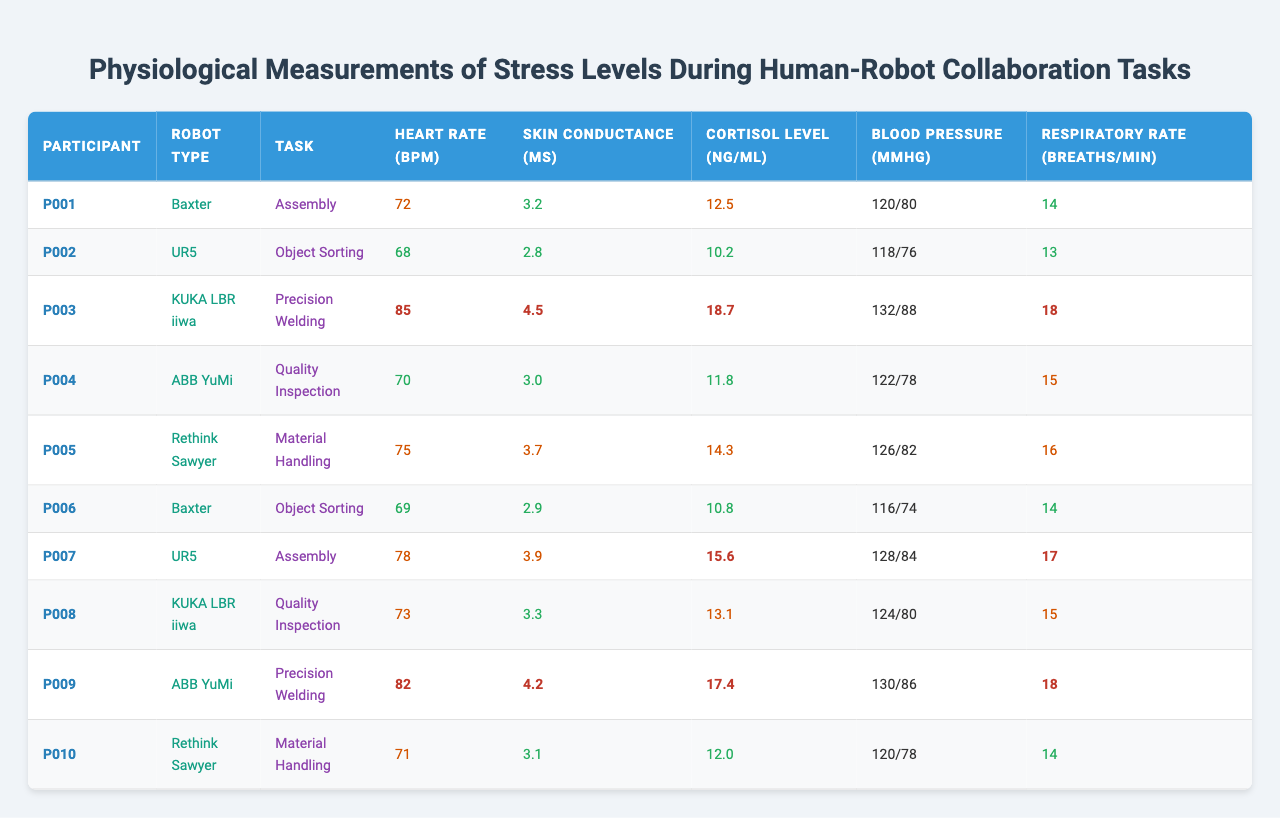What is the heart rate of participant P003? To find the heart rate of participant P003, look for their entry in the table. Participant P003 has a heart rate recorded as 85 bpm.
Answer: 85 bpm Which robot type had the highest skin conductance recorded? Examining the skin conductance values in the table, the highest recorded is for participant P003, who collaborated with the KUKA LBR iiwa robot and had a skin conductance of 4.5 μS.
Answer: KUKA LBR iiwa Is the cortisol level of participant P007 considered high? From the table, participant P007 has a cortisol level of 15.6 ng/mL. Since the threshold for high cortisol is above 15 ng/mL, this would be classified as high.
Answer: Yes What is the average respiratory rate across all participants? Adding up all respiratory rates: (14 + 13 + 18 + 15 + 16 + 14 + 17 + 15 + 18 + 14) =  162. There are 10 participants, so the average is 162 / 10 = 16.2.
Answer: 16.2 How many participants had a blood pressure reading higher than 125/80? Looking through the blood pressure readings, participants P003 (132/88), P005 (126/82), and P009 (130/86) had readings higher than 125/80, totaling 3 participants.
Answer: 3 What is the correlation between high heart rate and cortisol levels in the group? Review the table for heart rates above 80 bpm and their corresponding cortisol levels: P003 with 18.7 ng/mL, P007 with 15.6 ng/mL, and P009 with 17.4 ng/mL. All these participants exhibit high cortisol, indicating a possible correlation between high heart rate and increased cortisol levels.
Answer: Positive correlation Which collaboration task resulted in the most diverse physiological measures? Analyzing the tasks, "Precision Welding" shows high measures across participants P003 (high heart rate and cortisol), P009 (high heart rate and cortisol), indicating variability. Other tasks like "Object Sorting" show lower variation.
Answer: Precision Welding Which participant had the lowest skin conductance? In the table, the lowest skin conductance recorded is for participant P002, who had a skin conductance of 2.8 μS.
Answer: P002 What is the difference in heart rates between participants P001 and P007? Participant P001 has a heart rate of 72 bpm, while participant P007 has 78 bpm. The difference is 78 - 72 = 6 bpm.
Answer: 6 bpm Is there a task associated with the highest average heart rate? To determine this, calculate average heart rates for each task from the entries: Assembly, Object Sorting, etc. The assembly task average is higher at P001 (72) and P007 (78), giving an average of 75 bpm.
Answer: Yes, Assembly has the highest average 